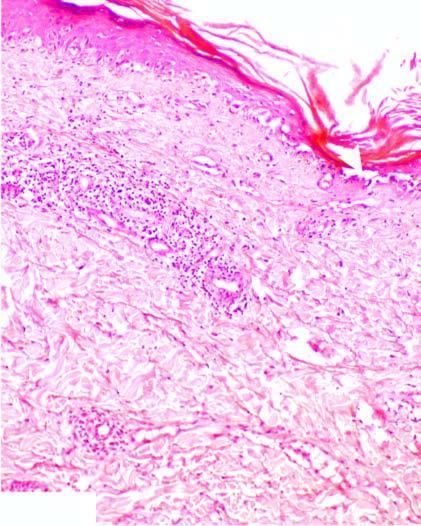what does the basal layer show?
Answer the question using a single word or phrase. Hydropic degeneration and loss of dermoepidermal junction 